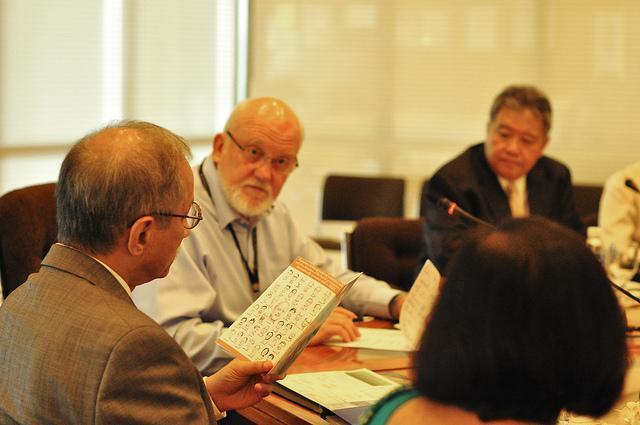How many bald men?
Give a very brief answer. 1. How many chairs are in the photo?
Give a very brief answer. 3. How many people are in the picture?
Give a very brief answer. 5. 